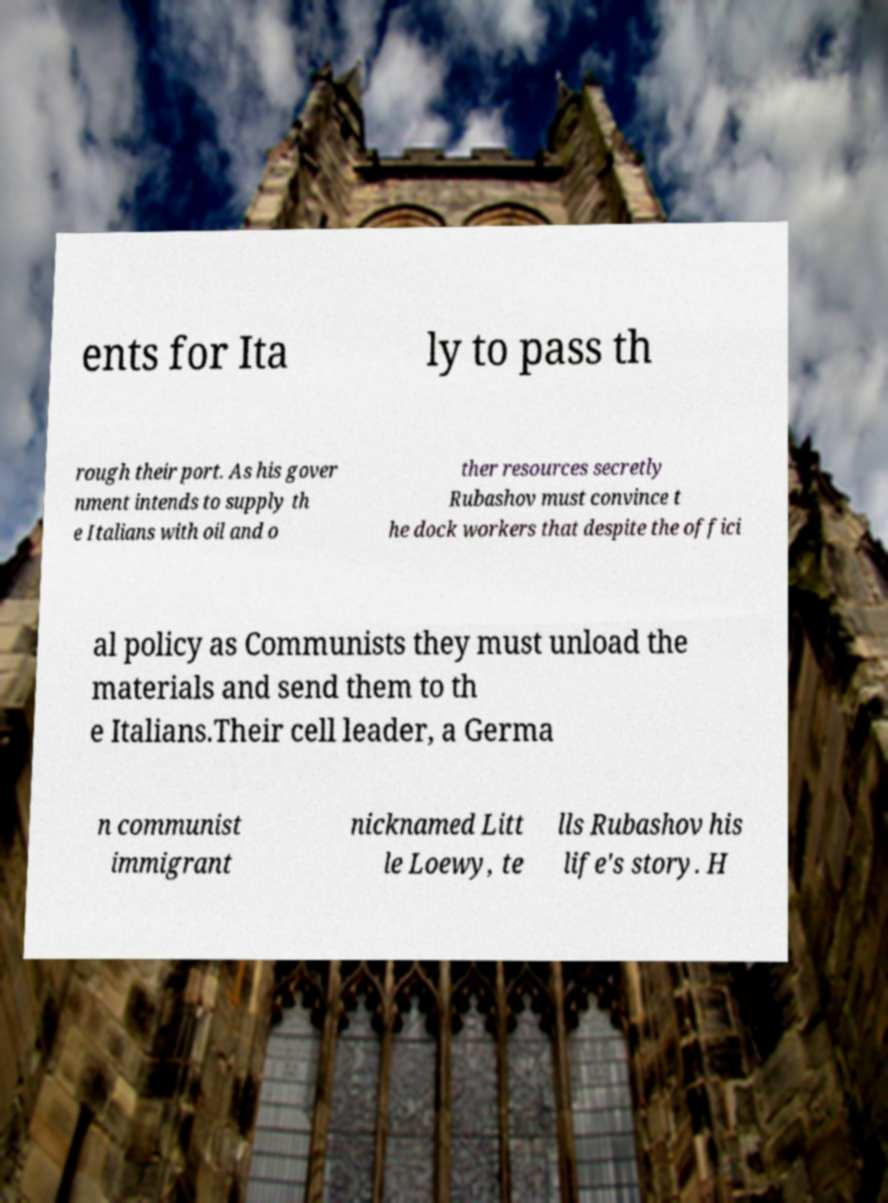There's text embedded in this image that I need extracted. Can you transcribe it verbatim? ents for Ita ly to pass th rough their port. As his gover nment intends to supply th e Italians with oil and o ther resources secretly Rubashov must convince t he dock workers that despite the offici al policy as Communists they must unload the materials and send them to th e Italians.Their cell leader, a Germa n communist immigrant nicknamed Litt le Loewy, te lls Rubashov his life's story. H 